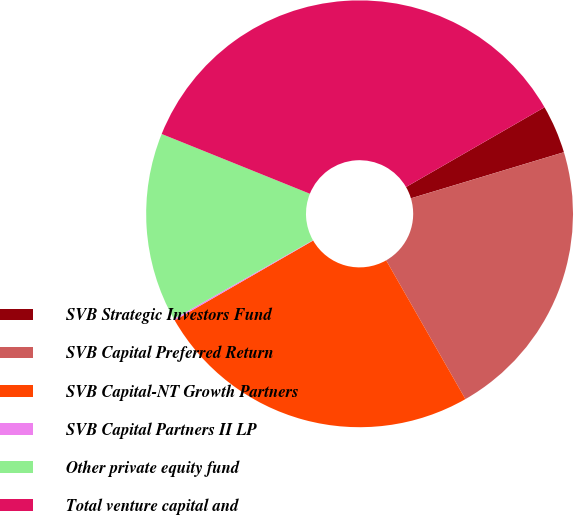Convert chart. <chart><loc_0><loc_0><loc_500><loc_500><pie_chart><fcel>SVB Strategic Investors Fund<fcel>SVB Capital Preferred Return<fcel>SVB Capital-NT Growth Partners<fcel>SVB Capital Partners II LP<fcel>Other private equity fund<fcel>Total venture capital and<nl><fcel>3.66%<fcel>21.4%<fcel>24.94%<fcel>0.12%<fcel>14.3%<fcel>35.58%<nl></chart> 